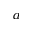<formula> <loc_0><loc_0><loc_500><loc_500>^ { a }</formula> 